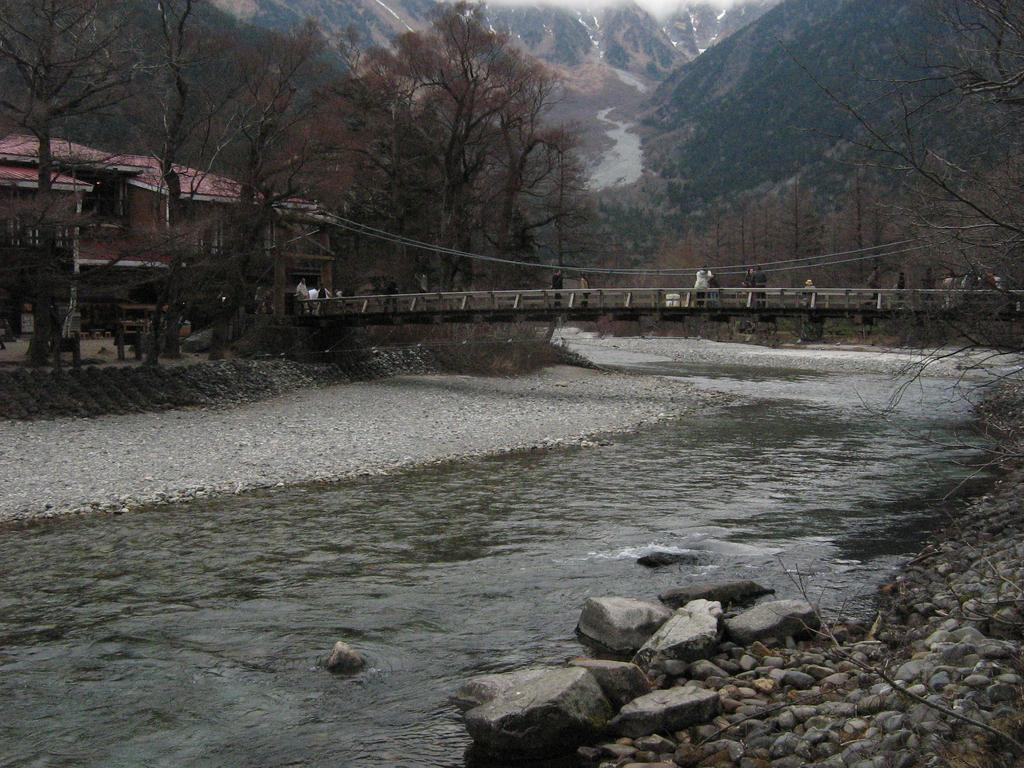What is located on the right side of the image? There is a tree and stones on the ground on the right side of the image. What can be seen in the image besides the tree and stones? There is water of a lake in the image. What is visible in the background of the image? There are trees, buildings, and mountains in the background of the image. Where is the sponge located in the image? There is no sponge present in the image. How many cars can be seen in the image? There are no cars visible in the image. 